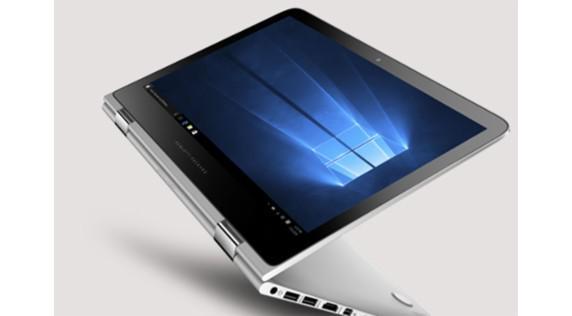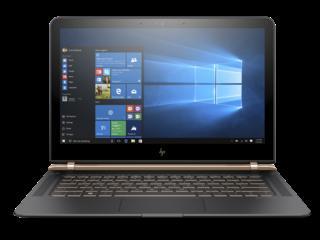The first image is the image on the left, the second image is the image on the right. Analyze the images presented: Is the assertion "the laptop on the right image has a black background" valid? Answer yes or no. Yes. 